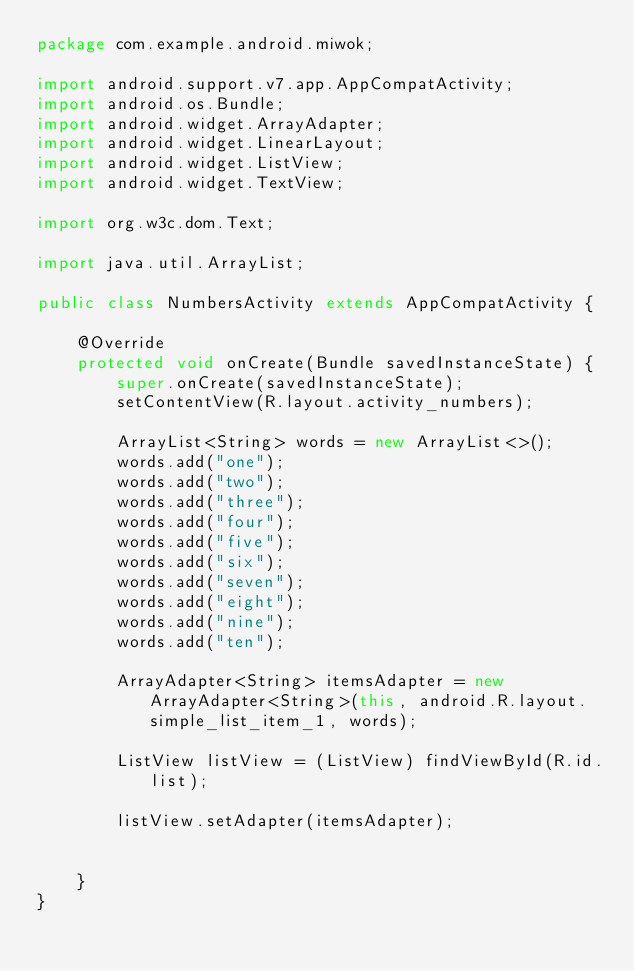Convert code to text. <code><loc_0><loc_0><loc_500><loc_500><_Java_>package com.example.android.miwok;

import android.support.v7.app.AppCompatActivity;
import android.os.Bundle;
import android.widget.ArrayAdapter;
import android.widget.LinearLayout;
import android.widget.ListView;
import android.widget.TextView;

import org.w3c.dom.Text;

import java.util.ArrayList;

public class NumbersActivity extends AppCompatActivity {

    @Override
    protected void onCreate(Bundle savedInstanceState) {
        super.onCreate(savedInstanceState);
        setContentView(R.layout.activity_numbers);

        ArrayList<String> words = new ArrayList<>();
        words.add("one");
        words.add("two");
        words.add("three");
        words.add("four");
        words.add("five");
        words.add("six");
        words.add("seven");
        words.add("eight");
        words.add("nine");
        words.add("ten");

        ArrayAdapter<String> itemsAdapter = new ArrayAdapter<String>(this, android.R.layout.simple_list_item_1, words);

        ListView listView = (ListView) findViewById(R.id.list);

        listView.setAdapter(itemsAdapter);


    }
}
</code> 